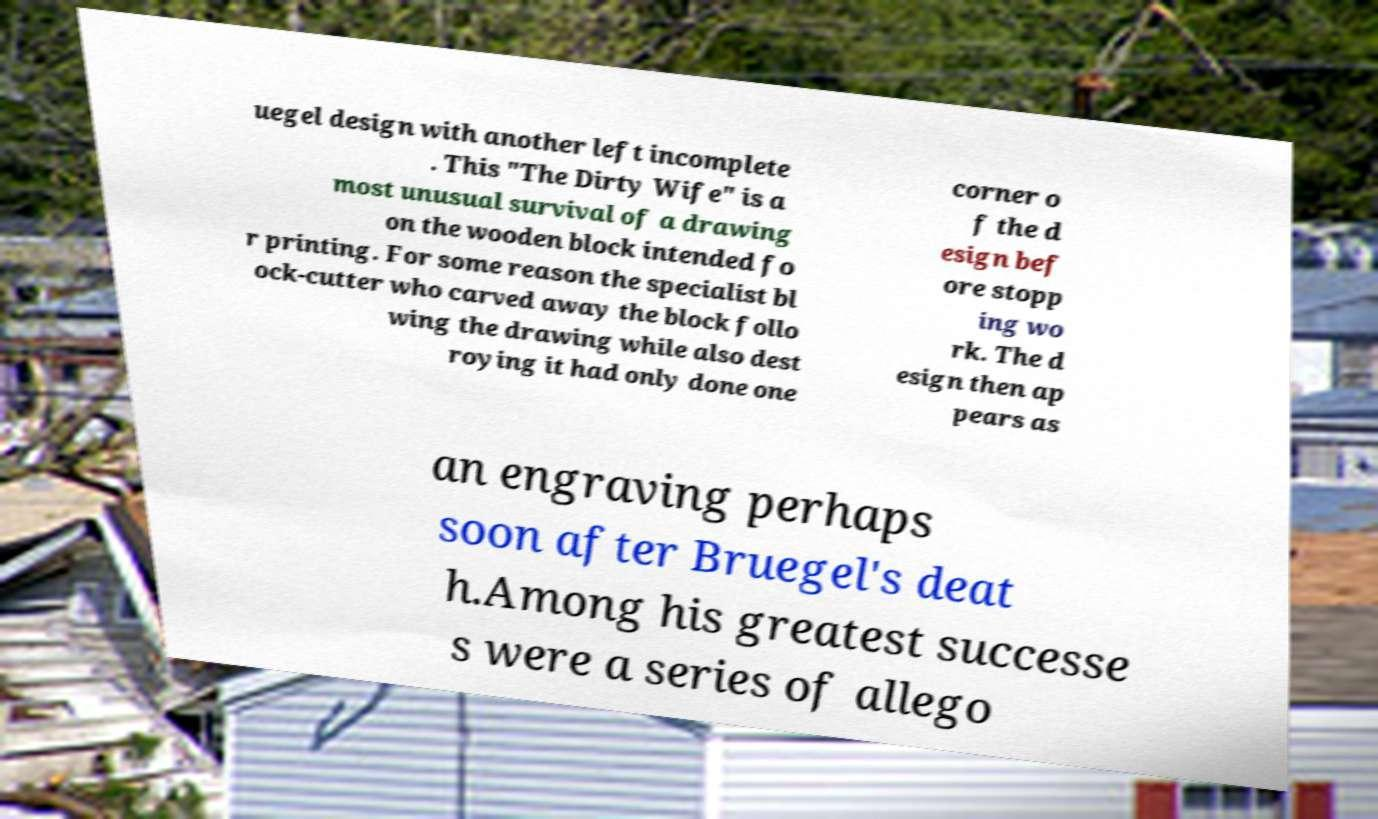Please read and relay the text visible in this image. What does it say? uegel design with another left incomplete . This "The Dirty Wife" is a most unusual survival of a drawing on the wooden block intended fo r printing. For some reason the specialist bl ock-cutter who carved away the block follo wing the drawing while also dest roying it had only done one corner o f the d esign bef ore stopp ing wo rk. The d esign then ap pears as an engraving perhaps soon after Bruegel's deat h.Among his greatest successe s were a series of allego 